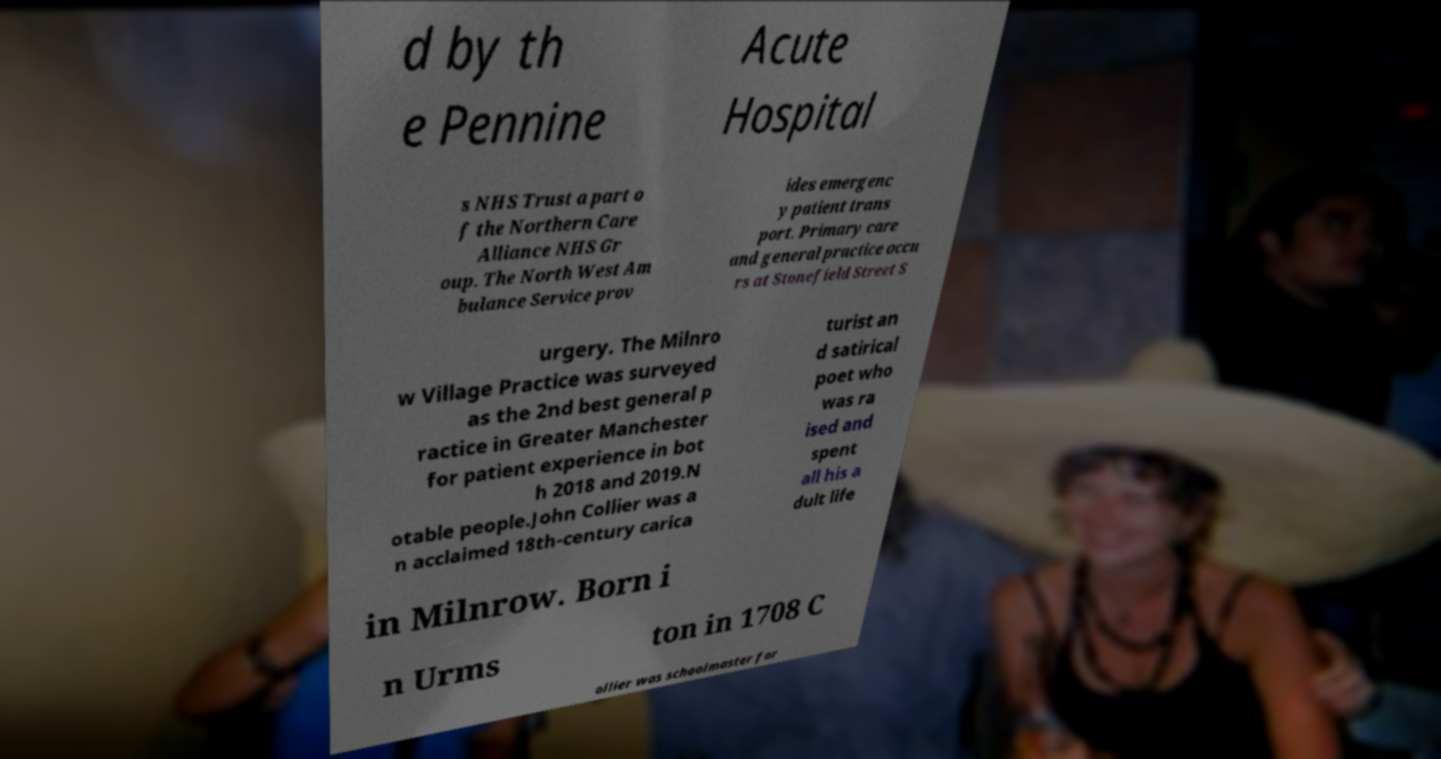Could you extract and type out the text from this image? d by th e Pennine Acute Hospital s NHS Trust a part o f the Northern Care Alliance NHS Gr oup. The North West Am bulance Service prov ides emergenc y patient trans port. Primary care and general practice occu rs at Stonefield Street S urgery. The Milnro w Village Practice was surveyed as the 2nd best general p ractice in Greater Manchester for patient experience in bot h 2018 and 2019.N otable people.John Collier was a n acclaimed 18th-century carica turist an d satirical poet who was ra ised and spent all his a dult life in Milnrow. Born i n Urms ton in 1708 C ollier was schoolmaster for 